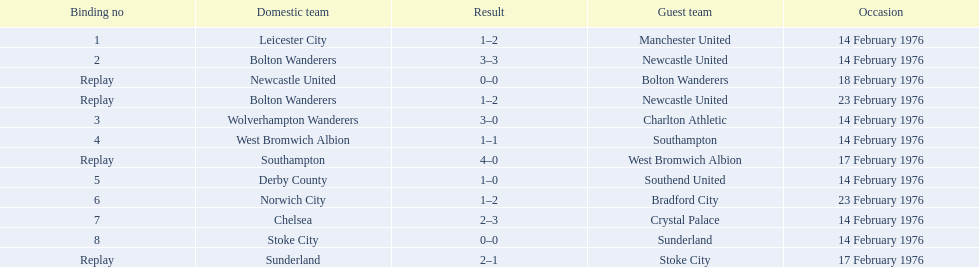What teams are featured in the game at the top of the table? Leicester City, Manchester United. Which of these two is the home team? Leicester City. 